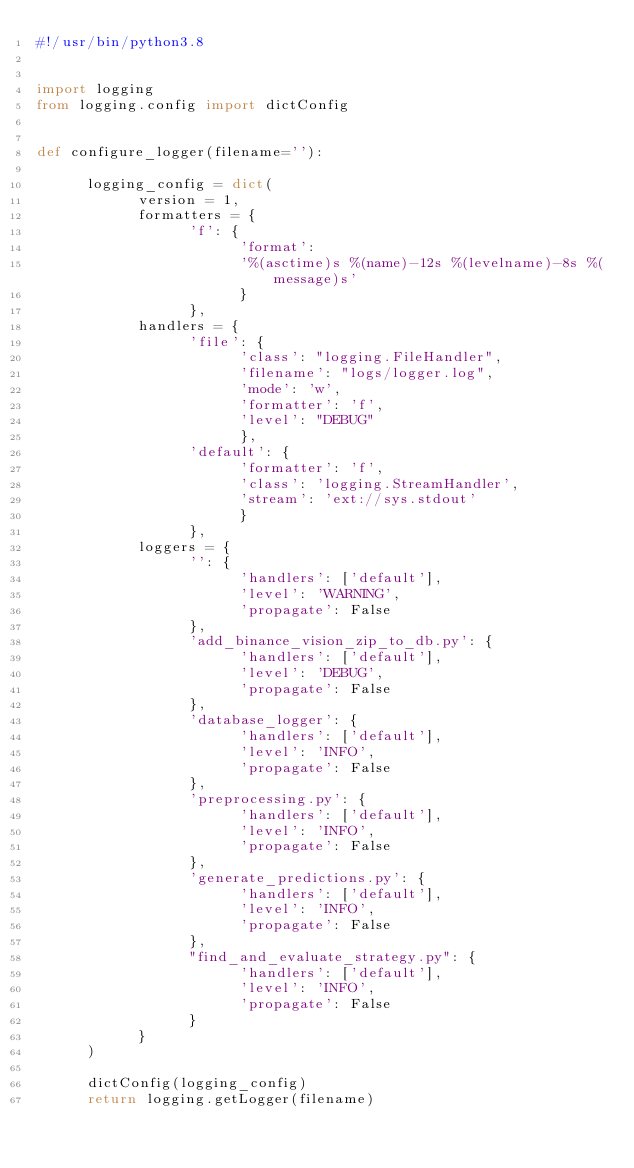<code> <loc_0><loc_0><loc_500><loc_500><_Python_>#!/usr/bin/python3.8


import logging
from logging.config import dictConfig


def configure_logger(filename=''):

      logging_config = dict(
            version = 1,
            formatters = {
                  'f': {
                        'format':
                        '%(asctime)s %(name)-12s %(levelname)-8s %(message)s'
                        }
                  },
            handlers = {
                  'file': {
                        'class': "logging.FileHandler",
                        'filename': "logs/logger.log",
                        'mode': 'w',
                        'formatter': 'f',
                        'level': "DEBUG"
                        },
                  'default': {
                        'formatter': 'f',
                        'class': 'logging.StreamHandler',
                        'stream': 'ext://sys.stdout'
                        }
                  },
            loggers = {
                  '': {
                        'handlers': ['default'],
                        'level': 'WARNING',
                        'propagate': False
                  },
                  'add_binance_vision_zip_to_db.py': {
                        'handlers': ['default'],
                        'level': 'DEBUG',
                        'propagate': False
                  },
                  'database_logger': {
                        'handlers': ['default'],
                        'level': 'INFO',
                        'propagate': False
                  },
                  'preprocessing.py': {
                        'handlers': ['default'],
                        'level': 'INFO',
                        'propagate': False
                  },
                  'generate_predictions.py': {
                        'handlers': ['default'],
                        'level': 'INFO',
                        'propagate': False
                  },
                  "find_and_evaluate_strategy.py": {
                        'handlers': ['default'],
                        'level': 'INFO',
                        'propagate': False
                  }
            }
      )

      dictConfig(logging_config)
      return logging.getLogger(filename)
</code> 